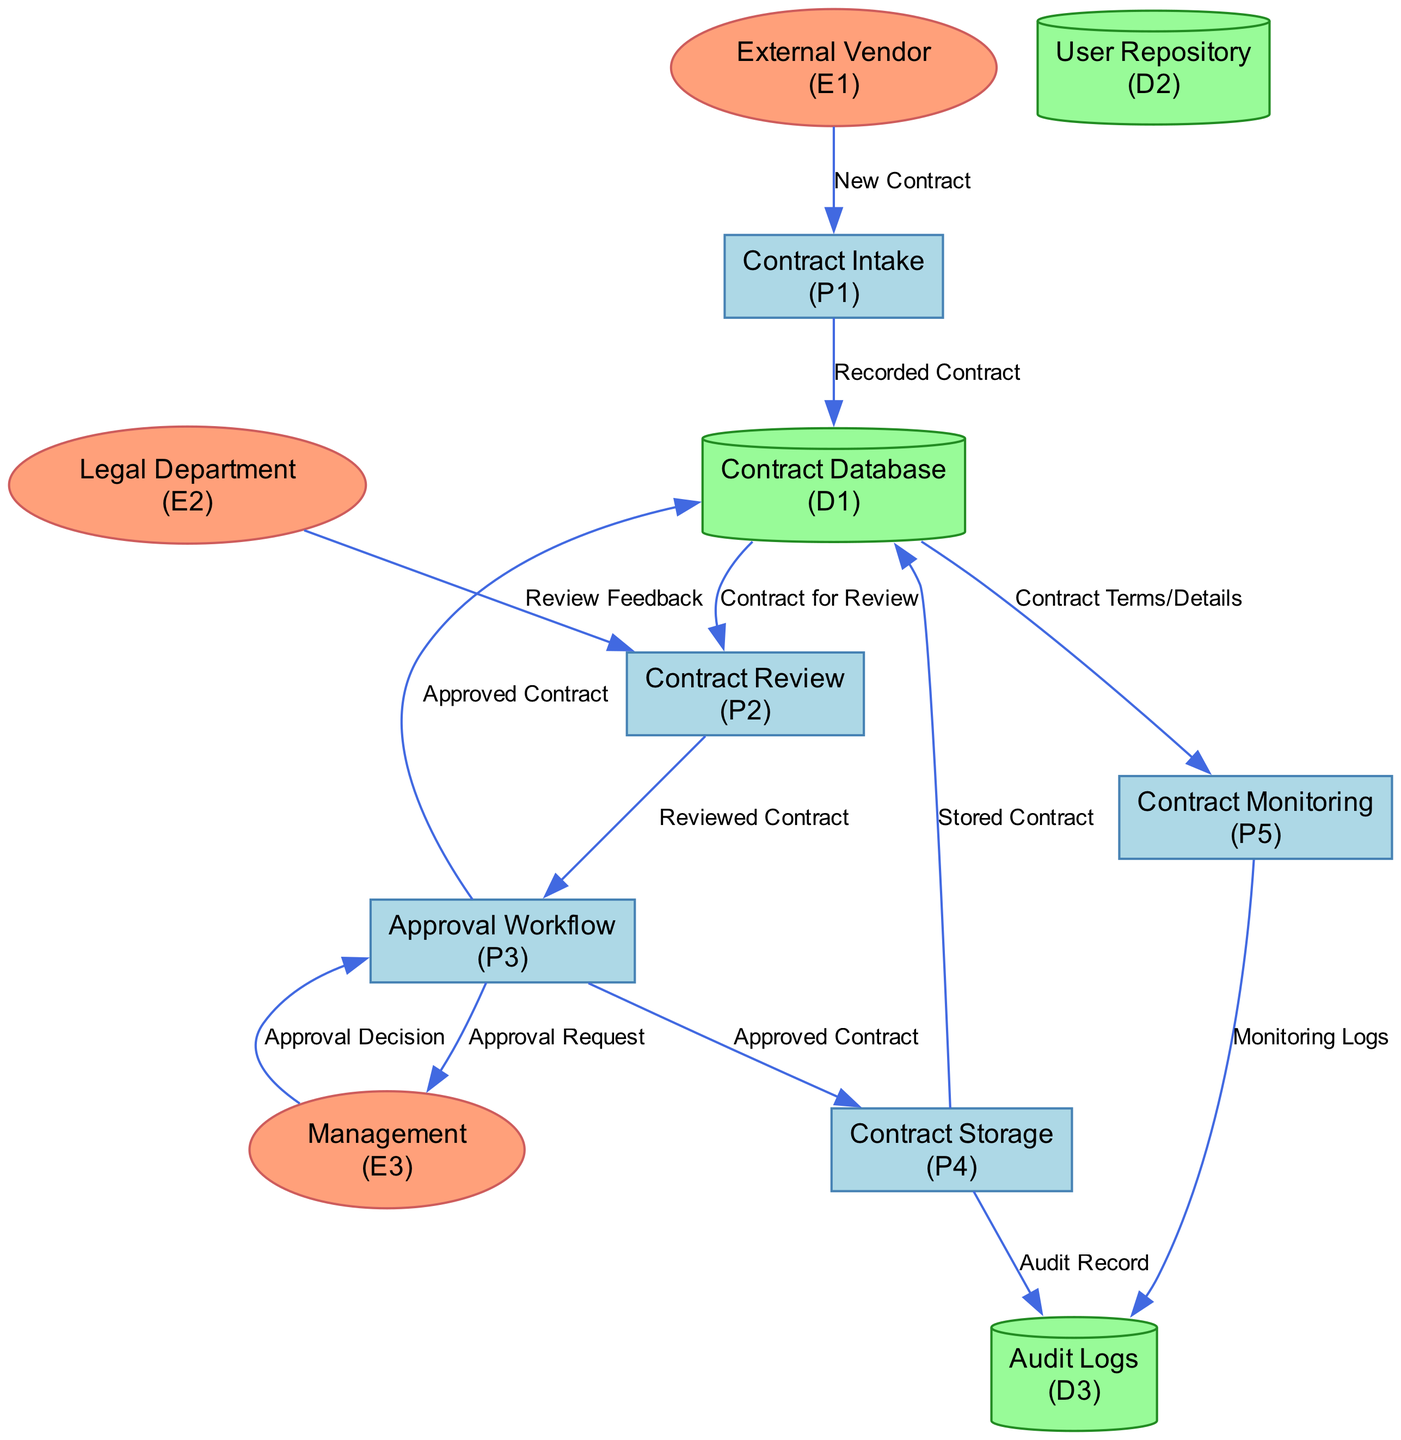What is the first process in the diagram? The first process is "Contract Intake," indicated as P1 in the diagram. It captures and records new contracts received.
Answer: Contract Intake How many data stores are depicted in the diagram? There are three data stores shown in the diagram: Contract Database, User Repository, and Audit Logs.
Answer: Three Which external entity provides new contracts? The external entity that provides new contracts is "External Vendor," represented as E1 in the diagram.
Answer: External Vendor What data is transferred from "Approval Workflow" to "Management"? "Approval Workflow" sends "Approval Request" to "Management," indicated in the data flow between P3 and E3.
Answer: Approval Request What is the last process in the diagram? The last process is "Contract Monitoring," which is referred to as P5 in the diagram for tracking contract milestones.
Answer: Contract Monitoring Which process receives "Review Feedback"? The process that receives "Review Feedback" is "Contract Review," indicated as P2 in the diagram, receiving input from the Legal Department (E2).
Answer: Contract Review How many external entities are involved in the contract management process? There are three external entities involved: External Vendor, Legal Department, and Management.
Answer: Three What data flows from "Contract Storage" to "Audit Logs"? "Contract Storage" sends "Audit Record" to "Audit Logs," as shown in the data flow from P4 to D3.
Answer: Audit Record Which data store holds all contract information? The data store that holds all contract information is the "Contract Database," identified as D1 in the diagram.
Answer: Contract Database 